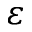<formula> <loc_0><loc_0><loc_500><loc_500>\varepsilon</formula> 